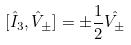Convert formula to latex. <formula><loc_0><loc_0><loc_500><loc_500>[ \hat { I } _ { 3 } , \hat { V } _ { \pm } ] = \pm \frac { 1 } { 2 } \hat { V _ { \pm } }</formula> 